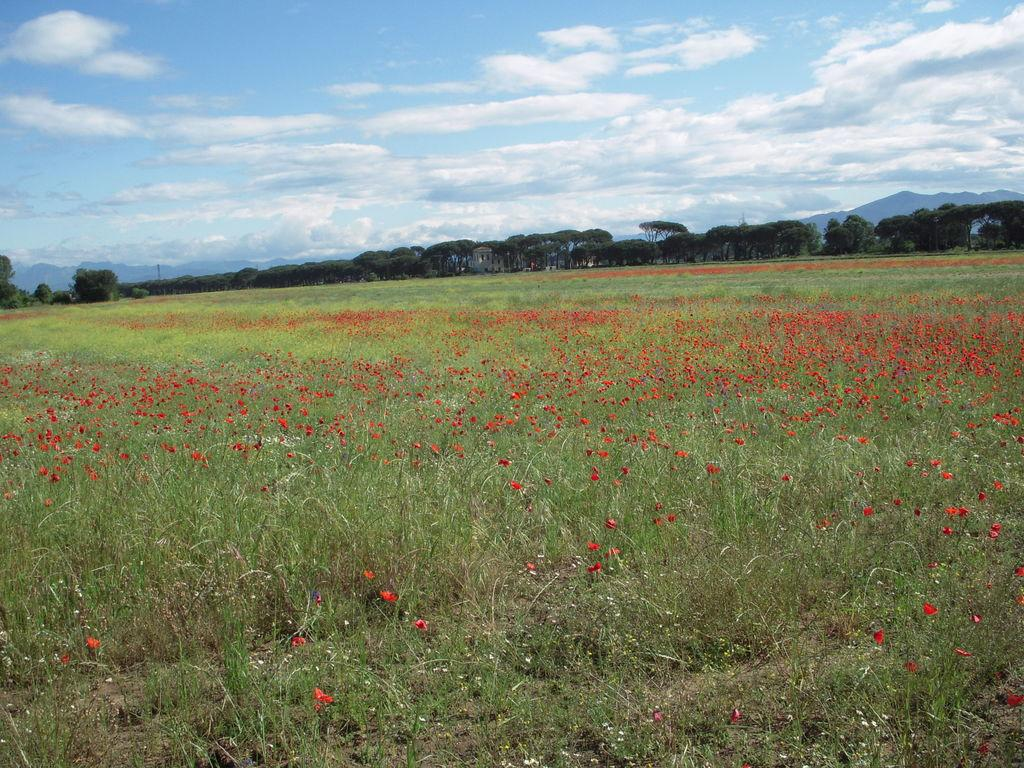What can be seen in the sky in the image? The sky is visible in the image, and there are clouds present. What type of natural features can be seen in the image? There are hills and trees visible in the image. Are there any plants with flowers in the image? Yes, there are plants with flowers present in the image. Where is the can of paint located in the image? There is no can of paint present in the image. What type of jewelry is hanging from the tree in the image? There is no jewelry, such as a locket, hanging from the tree in the image. 